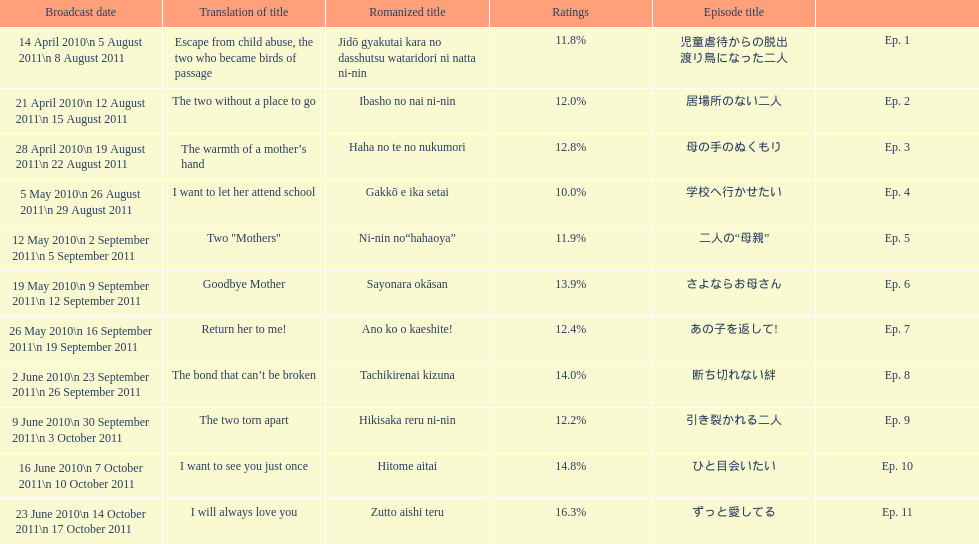How many episodes are listed? 11. 